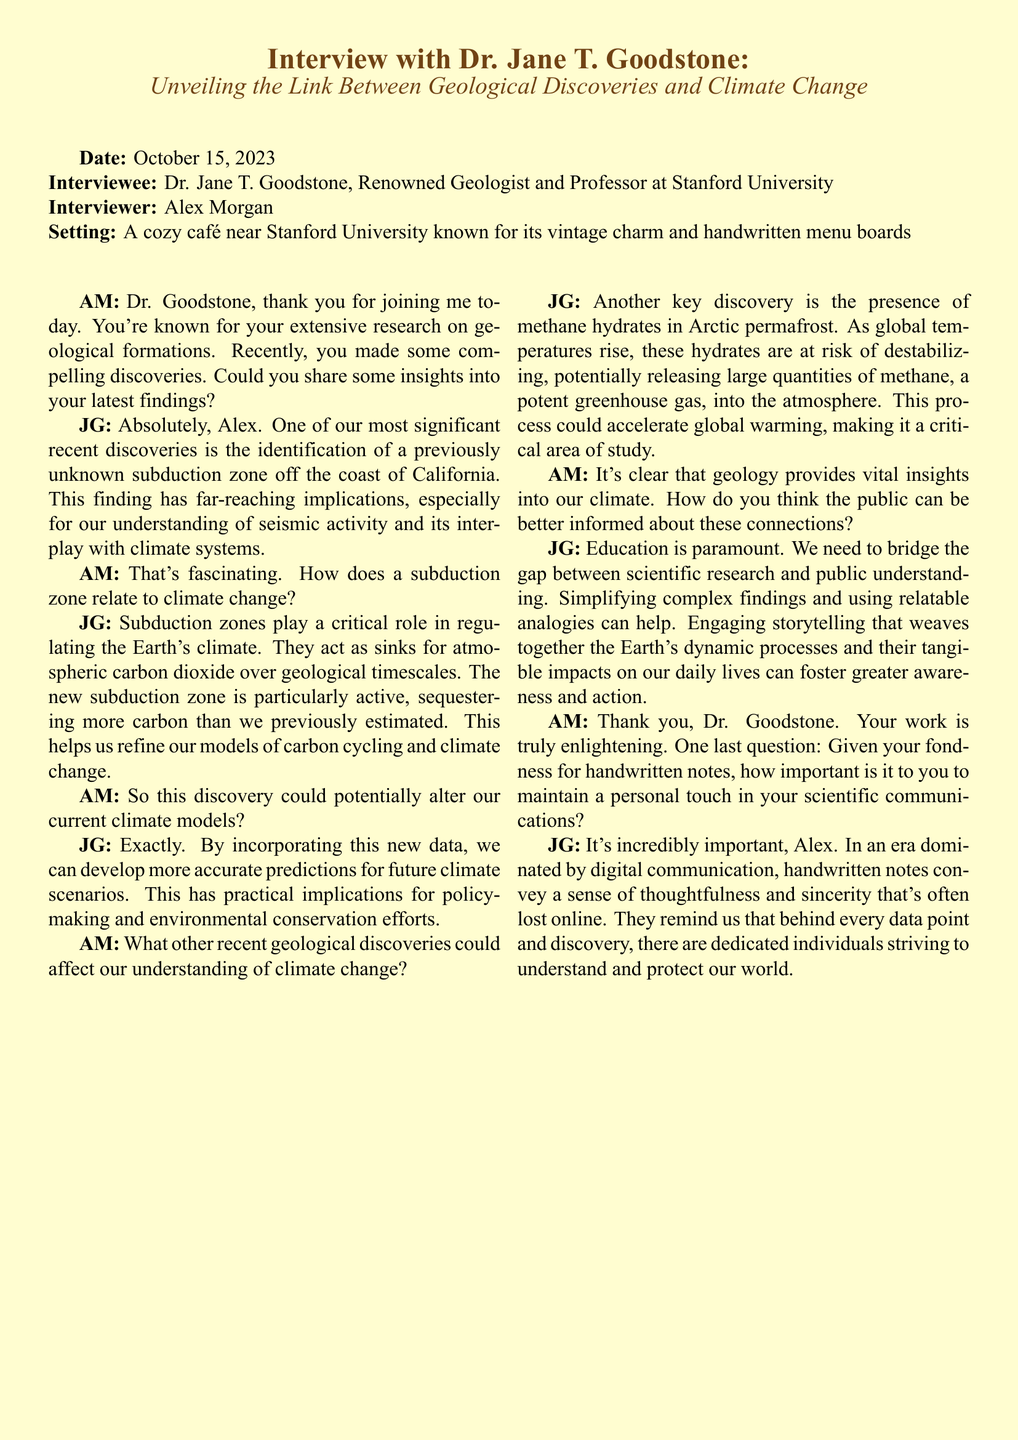What is the name of the interviewee? The interviewee is Dr. Jane T. Goodstone, a renowned geologist and professor.
Answer: Dr. Jane T. Goodstone What is the date of the interview? The date of the interview is provided in the document as October 15, 2023.
Answer: October 15, 2023 What significant finding did Dr. Goodstone's team discover? The significant finding is the identification of a previously unknown subduction zone off the coast of California.
Answer: Subduction zone How do subduction zones affect climate change? Subduction zones act as sinks for atmospheric carbon dioxide over geological timescales, influencing climate models.
Answer: Sinks for atmospheric carbon dioxide What is a key discovery related to Arctic permafrost? The presence of methane hydrates in Arctic permafrost is a key discovery that could release methane into the atmosphere.
Answer: Methane hydrates Why does Dr. Goodstone emphasize education? She believes education is paramount to bridge the gap between scientific research and public understanding.
Answer: Education is paramount What personal communication method does Dr. Goodstone prefer? She prefers handwritten notes for their thoughtfulness and sincerity in communication.
Answer: Handwritten notes What is the role of methane in climate change according to Dr. Goodstone? Methane is a potent greenhouse gas that could accelerate global warming if released from destabilized hydrates.
Answer: Potent greenhouse gas 